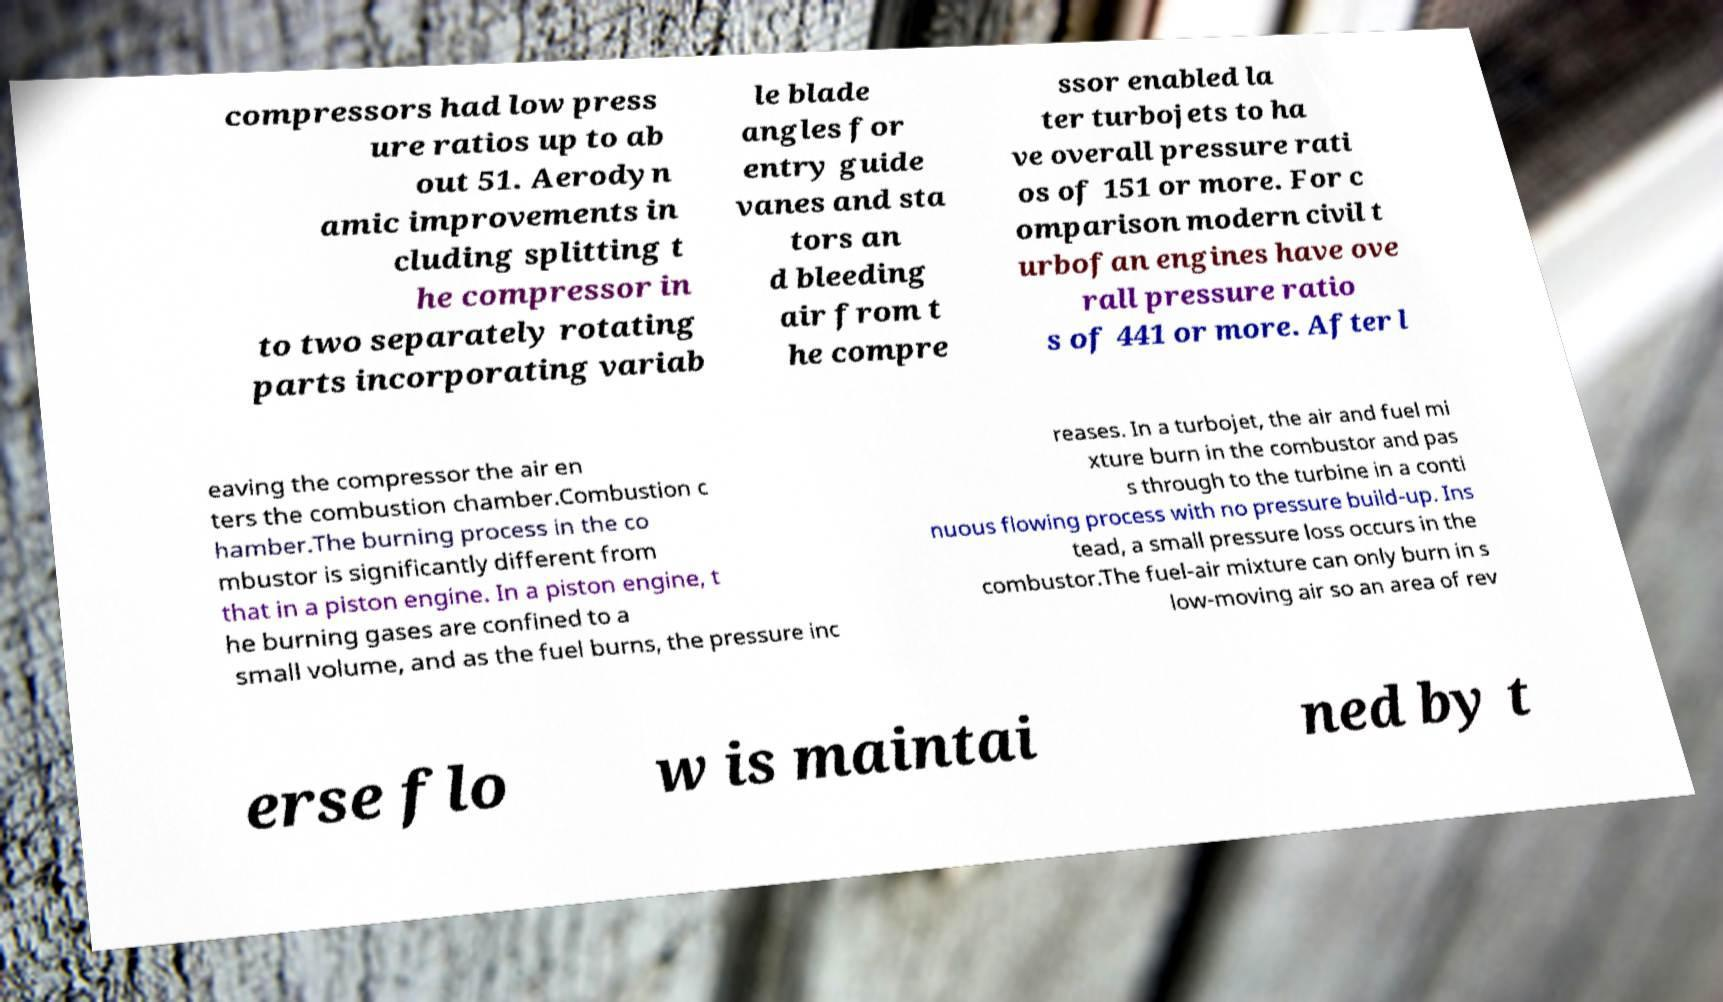Can you accurately transcribe the text from the provided image for me? compressors had low press ure ratios up to ab out 51. Aerodyn amic improvements in cluding splitting t he compressor in to two separately rotating parts incorporating variab le blade angles for entry guide vanes and sta tors an d bleeding air from t he compre ssor enabled la ter turbojets to ha ve overall pressure rati os of 151 or more. For c omparison modern civil t urbofan engines have ove rall pressure ratio s of 441 or more. After l eaving the compressor the air en ters the combustion chamber.Combustion c hamber.The burning process in the co mbustor is significantly different from that in a piston engine. In a piston engine, t he burning gases are confined to a small volume, and as the fuel burns, the pressure inc reases. In a turbojet, the air and fuel mi xture burn in the combustor and pas s through to the turbine in a conti nuous flowing process with no pressure build-up. Ins tead, a small pressure loss occurs in the combustor.The fuel-air mixture can only burn in s low-moving air so an area of rev erse flo w is maintai ned by t 